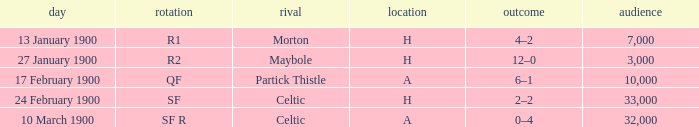Who played against in venue a on 17 february 1900? Partick Thistle. 